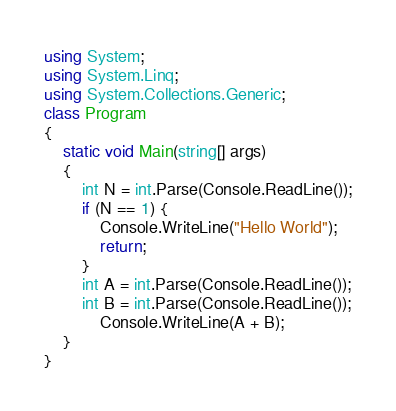Convert code to text. <code><loc_0><loc_0><loc_500><loc_500><_C#_>using System;
using System.Linq;
using System.Collections.Generic;
class Program
{
    static void Main(string[] args)
    {
        int N = int.Parse(Console.ReadLine());
        if (N == 1) {
            Console.WriteLine("Hello World");
            return;
        }
        int A = int.Parse(Console.ReadLine());
        int B = int.Parse(Console.ReadLine());
            Console.WriteLine(A + B);
    }
}
</code> 